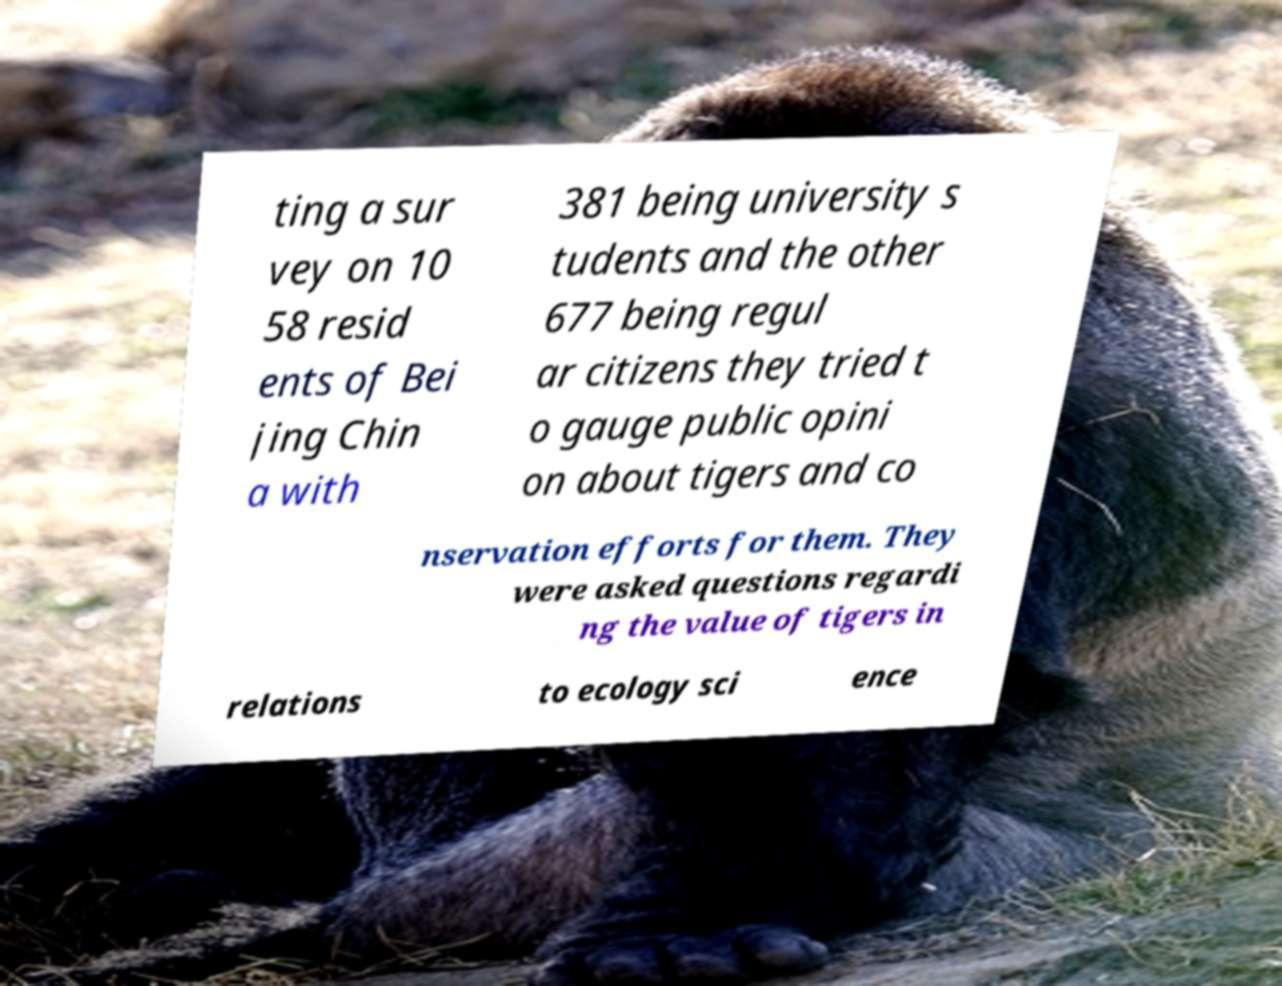There's text embedded in this image that I need extracted. Can you transcribe it verbatim? ting a sur vey on 10 58 resid ents of Bei jing Chin a with 381 being university s tudents and the other 677 being regul ar citizens they tried t o gauge public opini on about tigers and co nservation efforts for them. They were asked questions regardi ng the value of tigers in relations to ecology sci ence 